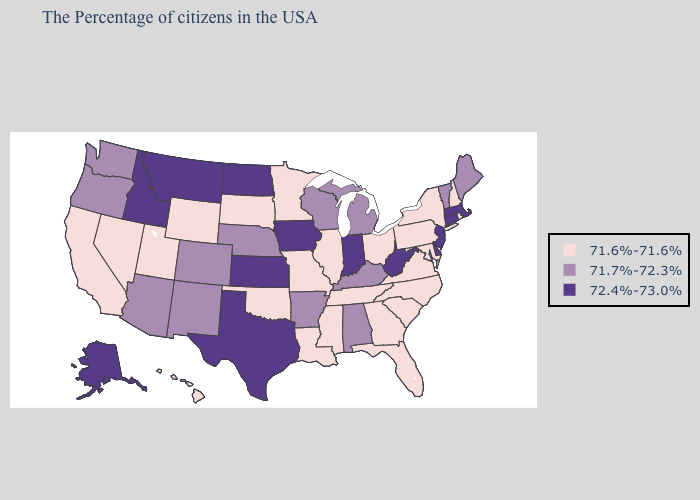Name the states that have a value in the range 71.7%-72.3%?
Keep it brief. Maine, Vermont, Michigan, Kentucky, Alabama, Wisconsin, Arkansas, Nebraska, Colorado, New Mexico, Arizona, Washington, Oregon. What is the highest value in the West ?
Give a very brief answer. 72.4%-73.0%. Which states have the lowest value in the USA?
Write a very short answer. Rhode Island, New Hampshire, New York, Maryland, Pennsylvania, Virginia, North Carolina, South Carolina, Ohio, Florida, Georgia, Tennessee, Illinois, Mississippi, Louisiana, Missouri, Minnesota, Oklahoma, South Dakota, Wyoming, Utah, Nevada, California, Hawaii. Does Pennsylvania have the lowest value in the Northeast?
Write a very short answer. Yes. Is the legend a continuous bar?
Give a very brief answer. No. Which states have the lowest value in the West?
Quick response, please. Wyoming, Utah, Nevada, California, Hawaii. Among the states that border Oregon , which have the highest value?
Concise answer only. Idaho. Does the first symbol in the legend represent the smallest category?
Be succinct. Yes. What is the highest value in the USA?
Be succinct. 72.4%-73.0%. What is the highest value in the USA?
Give a very brief answer. 72.4%-73.0%. Name the states that have a value in the range 72.4%-73.0%?
Quick response, please. Massachusetts, Connecticut, New Jersey, Delaware, West Virginia, Indiana, Iowa, Kansas, Texas, North Dakota, Montana, Idaho, Alaska. Does New Mexico have the lowest value in the USA?
Keep it brief. No. Among the states that border Illinois , does Missouri have the lowest value?
Keep it brief. Yes. What is the highest value in states that border South Carolina?
Write a very short answer. 71.6%-71.6%. Name the states that have a value in the range 71.7%-72.3%?
Answer briefly. Maine, Vermont, Michigan, Kentucky, Alabama, Wisconsin, Arkansas, Nebraska, Colorado, New Mexico, Arizona, Washington, Oregon. 